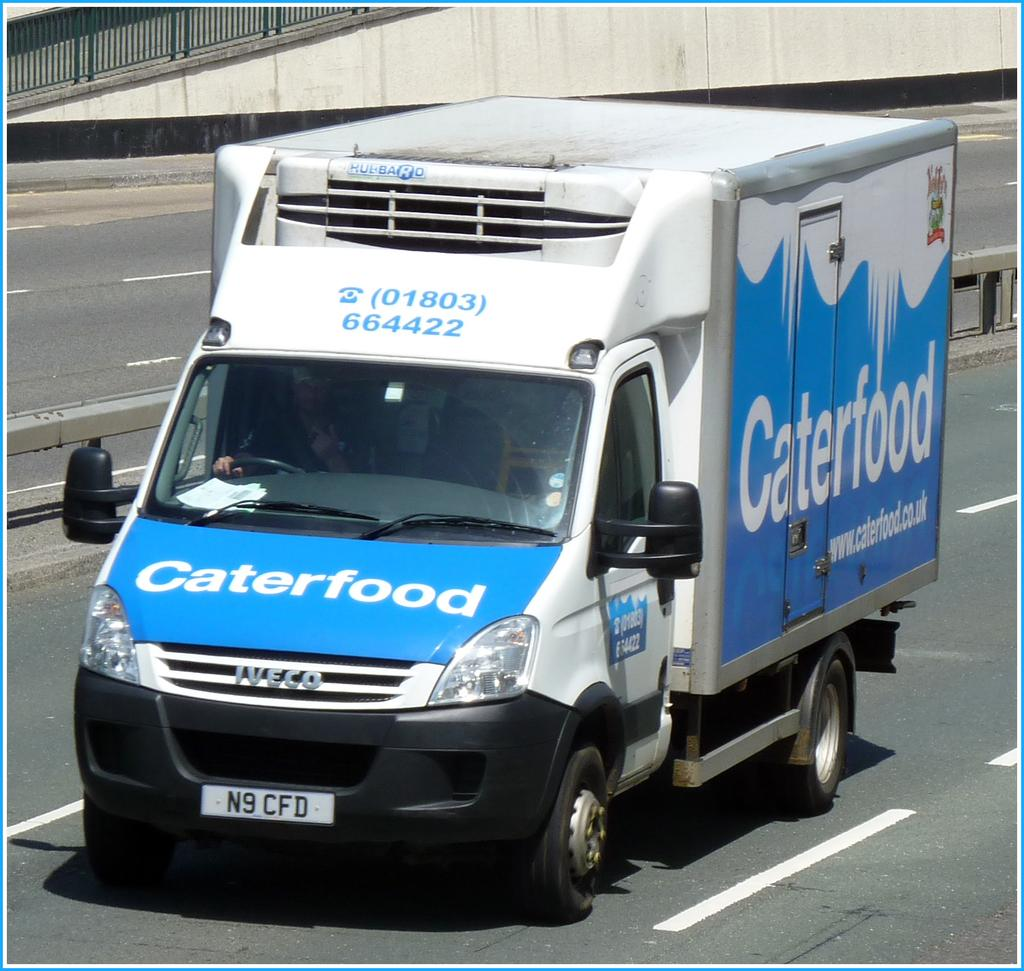What is on the road in the image? There is a vehicle on the road in the image. Can you describe the vehicle? Unfortunately, the facts provided do not give any details about the vehicle. Is there anyone inside the vehicle? Yes, a person is inside the vehicle. Can you see any tigers on the island in the image? There is no island or tiger present in the image; it only features a vehicle on the road with a person inside. 